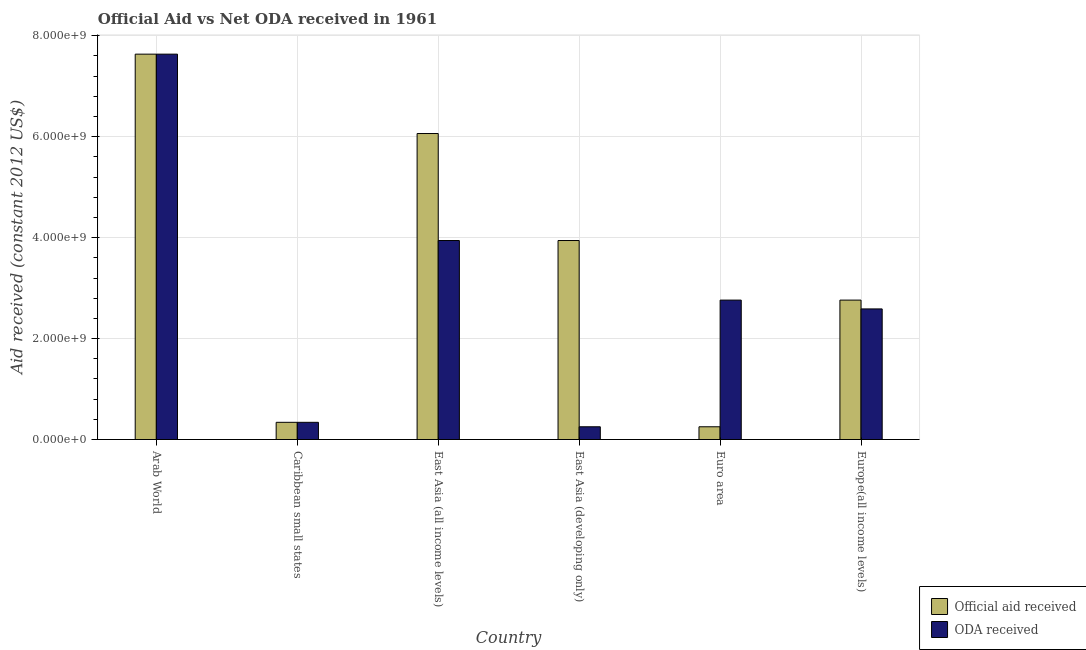How many different coloured bars are there?
Your response must be concise. 2. How many groups of bars are there?
Keep it short and to the point. 6. Are the number of bars per tick equal to the number of legend labels?
Your answer should be very brief. Yes. What is the label of the 1st group of bars from the left?
Offer a terse response. Arab World. What is the official aid received in Europe(all income levels)?
Keep it short and to the point. 2.76e+09. Across all countries, what is the maximum official aid received?
Your answer should be compact. 7.64e+09. Across all countries, what is the minimum official aid received?
Give a very brief answer. 2.53e+08. In which country was the official aid received maximum?
Offer a very short reply. Arab World. In which country was the official aid received minimum?
Offer a very short reply. Euro area. What is the total oda received in the graph?
Offer a terse response. 1.75e+1. What is the difference between the oda received in Caribbean small states and that in Europe(all income levels)?
Provide a succinct answer. -2.25e+09. What is the difference between the oda received in Europe(all income levels) and the official aid received in Arab World?
Make the answer very short. -5.05e+09. What is the average official aid received per country?
Make the answer very short. 3.50e+09. What is the difference between the official aid received and oda received in East Asia (all income levels)?
Your response must be concise. 2.12e+09. What is the ratio of the official aid received in Arab World to that in Euro area?
Make the answer very short. 30.24. Is the oda received in East Asia (all income levels) less than that in Europe(all income levels)?
Keep it short and to the point. No. Is the difference between the oda received in East Asia (developing only) and Euro area greater than the difference between the official aid received in East Asia (developing only) and Euro area?
Keep it short and to the point. No. What is the difference between the highest and the second highest official aid received?
Give a very brief answer. 1.57e+09. What is the difference between the highest and the lowest oda received?
Offer a terse response. 7.38e+09. In how many countries, is the oda received greater than the average oda received taken over all countries?
Give a very brief answer. 2. Is the sum of the oda received in Caribbean small states and East Asia (developing only) greater than the maximum official aid received across all countries?
Ensure brevity in your answer.  No. What does the 2nd bar from the left in Caribbean small states represents?
Offer a terse response. ODA received. What does the 2nd bar from the right in East Asia (developing only) represents?
Provide a short and direct response. Official aid received. How are the legend labels stacked?
Your answer should be very brief. Vertical. What is the title of the graph?
Your answer should be very brief. Official Aid vs Net ODA received in 1961 . What is the label or title of the Y-axis?
Provide a succinct answer. Aid received (constant 2012 US$). What is the Aid received (constant 2012 US$) of Official aid received in Arab World?
Give a very brief answer. 7.64e+09. What is the Aid received (constant 2012 US$) of ODA received in Arab World?
Provide a short and direct response. 7.64e+09. What is the Aid received (constant 2012 US$) in Official aid received in Caribbean small states?
Make the answer very short. 3.41e+08. What is the Aid received (constant 2012 US$) of ODA received in Caribbean small states?
Your answer should be very brief. 3.41e+08. What is the Aid received (constant 2012 US$) of Official aid received in East Asia (all income levels)?
Offer a terse response. 6.06e+09. What is the Aid received (constant 2012 US$) of ODA received in East Asia (all income levels)?
Give a very brief answer. 3.94e+09. What is the Aid received (constant 2012 US$) of Official aid received in East Asia (developing only)?
Your response must be concise. 3.94e+09. What is the Aid received (constant 2012 US$) in ODA received in East Asia (developing only)?
Make the answer very short. 2.53e+08. What is the Aid received (constant 2012 US$) of Official aid received in Euro area?
Provide a short and direct response. 2.53e+08. What is the Aid received (constant 2012 US$) in ODA received in Euro area?
Your answer should be compact. 2.76e+09. What is the Aid received (constant 2012 US$) of Official aid received in Europe(all income levels)?
Ensure brevity in your answer.  2.76e+09. What is the Aid received (constant 2012 US$) in ODA received in Europe(all income levels)?
Ensure brevity in your answer.  2.59e+09. Across all countries, what is the maximum Aid received (constant 2012 US$) in Official aid received?
Provide a succinct answer. 7.64e+09. Across all countries, what is the maximum Aid received (constant 2012 US$) of ODA received?
Give a very brief answer. 7.64e+09. Across all countries, what is the minimum Aid received (constant 2012 US$) in Official aid received?
Provide a succinct answer. 2.53e+08. Across all countries, what is the minimum Aid received (constant 2012 US$) of ODA received?
Make the answer very short. 2.53e+08. What is the total Aid received (constant 2012 US$) in Official aid received in the graph?
Offer a very short reply. 2.10e+1. What is the total Aid received (constant 2012 US$) of ODA received in the graph?
Your answer should be compact. 1.75e+1. What is the difference between the Aid received (constant 2012 US$) of Official aid received in Arab World and that in Caribbean small states?
Provide a succinct answer. 7.29e+09. What is the difference between the Aid received (constant 2012 US$) in ODA received in Arab World and that in Caribbean small states?
Keep it short and to the point. 7.29e+09. What is the difference between the Aid received (constant 2012 US$) in Official aid received in Arab World and that in East Asia (all income levels)?
Your response must be concise. 1.57e+09. What is the difference between the Aid received (constant 2012 US$) of ODA received in Arab World and that in East Asia (all income levels)?
Your answer should be very brief. 3.69e+09. What is the difference between the Aid received (constant 2012 US$) in Official aid received in Arab World and that in East Asia (developing only)?
Your answer should be compact. 3.69e+09. What is the difference between the Aid received (constant 2012 US$) of ODA received in Arab World and that in East Asia (developing only)?
Provide a succinct answer. 7.38e+09. What is the difference between the Aid received (constant 2012 US$) of Official aid received in Arab World and that in Euro area?
Your response must be concise. 7.38e+09. What is the difference between the Aid received (constant 2012 US$) of ODA received in Arab World and that in Euro area?
Keep it short and to the point. 4.87e+09. What is the difference between the Aid received (constant 2012 US$) of Official aid received in Arab World and that in Europe(all income levels)?
Your response must be concise. 4.87e+09. What is the difference between the Aid received (constant 2012 US$) in ODA received in Arab World and that in Europe(all income levels)?
Give a very brief answer. 5.05e+09. What is the difference between the Aid received (constant 2012 US$) of Official aid received in Caribbean small states and that in East Asia (all income levels)?
Ensure brevity in your answer.  -5.72e+09. What is the difference between the Aid received (constant 2012 US$) of ODA received in Caribbean small states and that in East Asia (all income levels)?
Offer a terse response. -3.60e+09. What is the difference between the Aid received (constant 2012 US$) in Official aid received in Caribbean small states and that in East Asia (developing only)?
Offer a very short reply. -3.60e+09. What is the difference between the Aid received (constant 2012 US$) in ODA received in Caribbean small states and that in East Asia (developing only)?
Provide a short and direct response. 8.83e+07. What is the difference between the Aid received (constant 2012 US$) of Official aid received in Caribbean small states and that in Euro area?
Keep it short and to the point. 8.83e+07. What is the difference between the Aid received (constant 2012 US$) in ODA received in Caribbean small states and that in Euro area?
Your response must be concise. -2.42e+09. What is the difference between the Aid received (constant 2012 US$) in Official aid received in Caribbean small states and that in Europe(all income levels)?
Give a very brief answer. -2.42e+09. What is the difference between the Aid received (constant 2012 US$) in ODA received in Caribbean small states and that in Europe(all income levels)?
Make the answer very short. -2.25e+09. What is the difference between the Aid received (constant 2012 US$) of Official aid received in East Asia (all income levels) and that in East Asia (developing only)?
Provide a short and direct response. 2.12e+09. What is the difference between the Aid received (constant 2012 US$) of ODA received in East Asia (all income levels) and that in East Asia (developing only)?
Make the answer very short. 3.69e+09. What is the difference between the Aid received (constant 2012 US$) in Official aid received in East Asia (all income levels) and that in Euro area?
Your answer should be compact. 5.81e+09. What is the difference between the Aid received (constant 2012 US$) in ODA received in East Asia (all income levels) and that in Euro area?
Offer a very short reply. 1.18e+09. What is the difference between the Aid received (constant 2012 US$) of Official aid received in East Asia (all income levels) and that in Europe(all income levels)?
Provide a succinct answer. 3.30e+09. What is the difference between the Aid received (constant 2012 US$) of ODA received in East Asia (all income levels) and that in Europe(all income levels)?
Give a very brief answer. 1.36e+09. What is the difference between the Aid received (constant 2012 US$) in Official aid received in East Asia (developing only) and that in Euro area?
Provide a short and direct response. 3.69e+09. What is the difference between the Aid received (constant 2012 US$) in ODA received in East Asia (developing only) and that in Euro area?
Ensure brevity in your answer.  -2.51e+09. What is the difference between the Aid received (constant 2012 US$) in Official aid received in East Asia (developing only) and that in Europe(all income levels)?
Provide a succinct answer. 1.18e+09. What is the difference between the Aid received (constant 2012 US$) of ODA received in East Asia (developing only) and that in Europe(all income levels)?
Give a very brief answer. -2.33e+09. What is the difference between the Aid received (constant 2012 US$) in Official aid received in Euro area and that in Europe(all income levels)?
Ensure brevity in your answer.  -2.51e+09. What is the difference between the Aid received (constant 2012 US$) of ODA received in Euro area and that in Europe(all income levels)?
Provide a succinct answer. 1.75e+08. What is the difference between the Aid received (constant 2012 US$) of Official aid received in Arab World and the Aid received (constant 2012 US$) of ODA received in Caribbean small states?
Ensure brevity in your answer.  7.29e+09. What is the difference between the Aid received (constant 2012 US$) in Official aid received in Arab World and the Aid received (constant 2012 US$) in ODA received in East Asia (all income levels)?
Keep it short and to the point. 3.69e+09. What is the difference between the Aid received (constant 2012 US$) in Official aid received in Arab World and the Aid received (constant 2012 US$) in ODA received in East Asia (developing only)?
Offer a very short reply. 7.38e+09. What is the difference between the Aid received (constant 2012 US$) in Official aid received in Arab World and the Aid received (constant 2012 US$) in ODA received in Euro area?
Offer a very short reply. 4.87e+09. What is the difference between the Aid received (constant 2012 US$) in Official aid received in Arab World and the Aid received (constant 2012 US$) in ODA received in Europe(all income levels)?
Your answer should be very brief. 5.05e+09. What is the difference between the Aid received (constant 2012 US$) in Official aid received in Caribbean small states and the Aid received (constant 2012 US$) in ODA received in East Asia (all income levels)?
Make the answer very short. -3.60e+09. What is the difference between the Aid received (constant 2012 US$) in Official aid received in Caribbean small states and the Aid received (constant 2012 US$) in ODA received in East Asia (developing only)?
Offer a very short reply. 8.83e+07. What is the difference between the Aid received (constant 2012 US$) of Official aid received in Caribbean small states and the Aid received (constant 2012 US$) of ODA received in Euro area?
Offer a very short reply. -2.42e+09. What is the difference between the Aid received (constant 2012 US$) in Official aid received in Caribbean small states and the Aid received (constant 2012 US$) in ODA received in Europe(all income levels)?
Your answer should be compact. -2.25e+09. What is the difference between the Aid received (constant 2012 US$) of Official aid received in East Asia (all income levels) and the Aid received (constant 2012 US$) of ODA received in East Asia (developing only)?
Offer a terse response. 5.81e+09. What is the difference between the Aid received (constant 2012 US$) in Official aid received in East Asia (all income levels) and the Aid received (constant 2012 US$) in ODA received in Euro area?
Provide a succinct answer. 3.30e+09. What is the difference between the Aid received (constant 2012 US$) in Official aid received in East Asia (all income levels) and the Aid received (constant 2012 US$) in ODA received in Europe(all income levels)?
Offer a very short reply. 3.48e+09. What is the difference between the Aid received (constant 2012 US$) in Official aid received in East Asia (developing only) and the Aid received (constant 2012 US$) in ODA received in Euro area?
Give a very brief answer. 1.18e+09. What is the difference between the Aid received (constant 2012 US$) of Official aid received in East Asia (developing only) and the Aid received (constant 2012 US$) of ODA received in Europe(all income levels)?
Make the answer very short. 1.36e+09. What is the difference between the Aid received (constant 2012 US$) in Official aid received in Euro area and the Aid received (constant 2012 US$) in ODA received in Europe(all income levels)?
Your answer should be compact. -2.33e+09. What is the average Aid received (constant 2012 US$) of Official aid received per country?
Make the answer very short. 3.50e+09. What is the average Aid received (constant 2012 US$) in ODA received per country?
Make the answer very short. 2.92e+09. What is the difference between the Aid received (constant 2012 US$) in Official aid received and Aid received (constant 2012 US$) in ODA received in Arab World?
Provide a succinct answer. 0. What is the difference between the Aid received (constant 2012 US$) of Official aid received and Aid received (constant 2012 US$) of ODA received in Caribbean small states?
Keep it short and to the point. 0. What is the difference between the Aid received (constant 2012 US$) in Official aid received and Aid received (constant 2012 US$) in ODA received in East Asia (all income levels)?
Offer a very short reply. 2.12e+09. What is the difference between the Aid received (constant 2012 US$) in Official aid received and Aid received (constant 2012 US$) in ODA received in East Asia (developing only)?
Offer a terse response. 3.69e+09. What is the difference between the Aid received (constant 2012 US$) of Official aid received and Aid received (constant 2012 US$) of ODA received in Euro area?
Offer a very short reply. -2.51e+09. What is the difference between the Aid received (constant 2012 US$) of Official aid received and Aid received (constant 2012 US$) of ODA received in Europe(all income levels)?
Ensure brevity in your answer.  1.75e+08. What is the ratio of the Aid received (constant 2012 US$) of Official aid received in Arab World to that in Caribbean small states?
Your answer should be very brief. 22.4. What is the ratio of the Aid received (constant 2012 US$) of ODA received in Arab World to that in Caribbean small states?
Make the answer very short. 22.4. What is the ratio of the Aid received (constant 2012 US$) in Official aid received in Arab World to that in East Asia (all income levels)?
Make the answer very short. 1.26. What is the ratio of the Aid received (constant 2012 US$) of ODA received in Arab World to that in East Asia (all income levels)?
Your answer should be compact. 1.94. What is the ratio of the Aid received (constant 2012 US$) in Official aid received in Arab World to that in East Asia (developing only)?
Make the answer very short. 1.94. What is the ratio of the Aid received (constant 2012 US$) in ODA received in Arab World to that in East Asia (developing only)?
Ensure brevity in your answer.  30.24. What is the ratio of the Aid received (constant 2012 US$) in Official aid received in Arab World to that in Euro area?
Your answer should be very brief. 30.24. What is the ratio of the Aid received (constant 2012 US$) of ODA received in Arab World to that in Euro area?
Offer a very short reply. 2.76. What is the ratio of the Aid received (constant 2012 US$) in Official aid received in Arab World to that in Europe(all income levels)?
Offer a very short reply. 2.76. What is the ratio of the Aid received (constant 2012 US$) in ODA received in Arab World to that in Europe(all income levels)?
Make the answer very short. 2.95. What is the ratio of the Aid received (constant 2012 US$) in Official aid received in Caribbean small states to that in East Asia (all income levels)?
Offer a very short reply. 0.06. What is the ratio of the Aid received (constant 2012 US$) in ODA received in Caribbean small states to that in East Asia (all income levels)?
Your answer should be very brief. 0.09. What is the ratio of the Aid received (constant 2012 US$) of Official aid received in Caribbean small states to that in East Asia (developing only)?
Ensure brevity in your answer.  0.09. What is the ratio of the Aid received (constant 2012 US$) in ODA received in Caribbean small states to that in East Asia (developing only)?
Your answer should be compact. 1.35. What is the ratio of the Aid received (constant 2012 US$) of Official aid received in Caribbean small states to that in Euro area?
Keep it short and to the point. 1.35. What is the ratio of the Aid received (constant 2012 US$) in ODA received in Caribbean small states to that in Euro area?
Ensure brevity in your answer.  0.12. What is the ratio of the Aid received (constant 2012 US$) of Official aid received in Caribbean small states to that in Europe(all income levels)?
Offer a very short reply. 0.12. What is the ratio of the Aid received (constant 2012 US$) of ODA received in Caribbean small states to that in Europe(all income levels)?
Make the answer very short. 0.13. What is the ratio of the Aid received (constant 2012 US$) of Official aid received in East Asia (all income levels) to that in East Asia (developing only)?
Offer a very short reply. 1.54. What is the ratio of the Aid received (constant 2012 US$) of ODA received in East Asia (all income levels) to that in East Asia (developing only)?
Offer a very short reply. 15.61. What is the ratio of the Aid received (constant 2012 US$) in Official aid received in East Asia (all income levels) to that in Euro area?
Provide a succinct answer. 24.01. What is the ratio of the Aid received (constant 2012 US$) in ODA received in East Asia (all income levels) to that in Euro area?
Your answer should be compact. 1.43. What is the ratio of the Aid received (constant 2012 US$) of Official aid received in East Asia (all income levels) to that in Europe(all income levels)?
Keep it short and to the point. 2.19. What is the ratio of the Aid received (constant 2012 US$) of ODA received in East Asia (all income levels) to that in Europe(all income levels)?
Give a very brief answer. 1.52. What is the ratio of the Aid received (constant 2012 US$) of Official aid received in East Asia (developing only) to that in Euro area?
Provide a short and direct response. 15.61. What is the ratio of the Aid received (constant 2012 US$) in ODA received in East Asia (developing only) to that in Euro area?
Offer a terse response. 0.09. What is the ratio of the Aid received (constant 2012 US$) of Official aid received in East Asia (developing only) to that in Europe(all income levels)?
Your answer should be compact. 1.43. What is the ratio of the Aid received (constant 2012 US$) in ODA received in East Asia (developing only) to that in Europe(all income levels)?
Your answer should be compact. 0.1. What is the ratio of the Aid received (constant 2012 US$) of Official aid received in Euro area to that in Europe(all income levels)?
Provide a succinct answer. 0.09. What is the ratio of the Aid received (constant 2012 US$) in ODA received in Euro area to that in Europe(all income levels)?
Offer a very short reply. 1.07. What is the difference between the highest and the second highest Aid received (constant 2012 US$) of Official aid received?
Keep it short and to the point. 1.57e+09. What is the difference between the highest and the second highest Aid received (constant 2012 US$) in ODA received?
Your response must be concise. 3.69e+09. What is the difference between the highest and the lowest Aid received (constant 2012 US$) of Official aid received?
Offer a very short reply. 7.38e+09. What is the difference between the highest and the lowest Aid received (constant 2012 US$) in ODA received?
Give a very brief answer. 7.38e+09. 